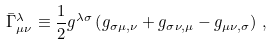Convert formula to latex. <formula><loc_0><loc_0><loc_500><loc_500>\bar { \Gamma } _ { \mu \nu } ^ { \lambda } \equiv \frac { 1 } { 2 } g ^ { \lambda \sigma } \left ( g _ { \sigma \mu , \nu } + g _ { \sigma \nu , \mu } - g _ { \mu \nu , \sigma } \right ) \, ,</formula> 